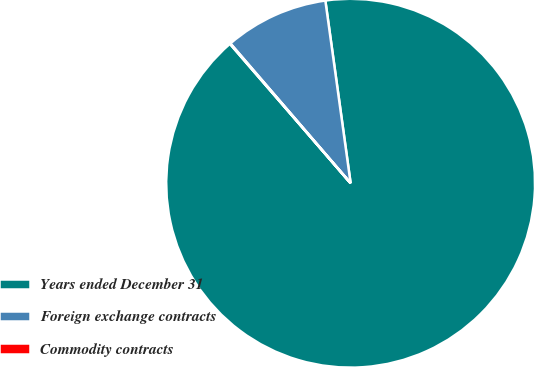<chart> <loc_0><loc_0><loc_500><loc_500><pie_chart><fcel>Years ended December 31<fcel>Foreign exchange contracts<fcel>Commodity contracts<nl><fcel>90.83%<fcel>9.12%<fcel>0.05%<nl></chart> 